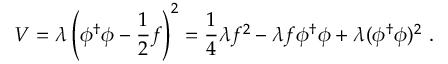<formula> <loc_0><loc_0><loc_500><loc_500>V = \lambda \left ( \phi ^ { \dagger } \phi - \frac { 1 } { 2 } f \right ) ^ { 2 } = \frac { 1 } { 4 } \lambda f ^ { 2 } - \lambda f \phi ^ { \dagger } \phi + \lambda ( \phi ^ { \dagger } \phi ) ^ { 2 } .</formula> 